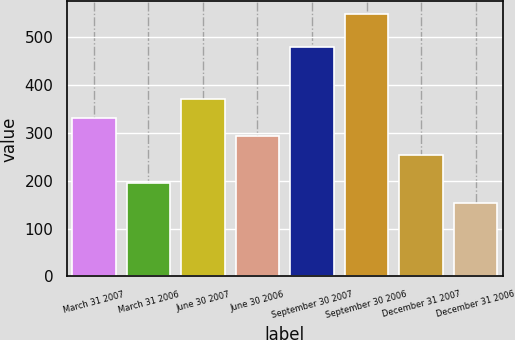<chart> <loc_0><loc_0><loc_500><loc_500><bar_chart><fcel>March 31 2007<fcel>March 31 2006<fcel>June 30 2007<fcel>June 30 2006<fcel>September 30 2007<fcel>September 30 2006<fcel>December 31 2007<fcel>December 31 2006<nl><fcel>331.6<fcel>196<fcel>370.9<fcel>292.3<fcel>479<fcel>547<fcel>253<fcel>154<nl></chart> 